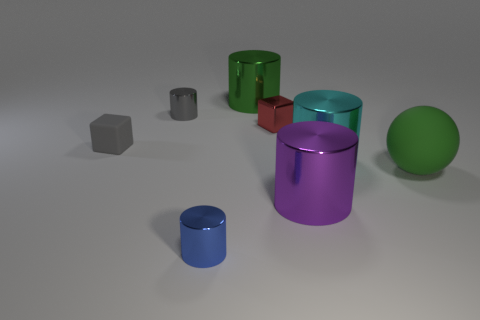There is another rubber block that is the same size as the red block; what color is it?
Your answer should be compact. Gray. What number of rubber objects are tiny cylinders or yellow cubes?
Your response must be concise. 0. There is a small cube that is made of the same material as the gray cylinder; what is its color?
Your answer should be very brief. Red. There is a green object on the left side of the big cyan metallic cylinder that is in front of the gray matte thing; what is its material?
Keep it short and to the point. Metal. How many objects are metallic cylinders that are in front of the cyan thing or cyan metal objects behind the green rubber object?
Give a very brief answer. 3. There is a matte object that is on the right side of the small cylinder that is on the right side of the small object that is behind the tiny red shiny block; what size is it?
Your response must be concise. Large. Is the number of small metallic blocks that are in front of the sphere the same as the number of purple metal cubes?
Your response must be concise. Yes. Is there anything else that is the same shape as the large green rubber thing?
Offer a very short reply. No. There is a small rubber thing; does it have the same shape as the small object to the right of the blue metallic object?
Your response must be concise. Yes. There is a rubber object that is the same shape as the tiny red shiny object; what is its size?
Your answer should be very brief. Small. 